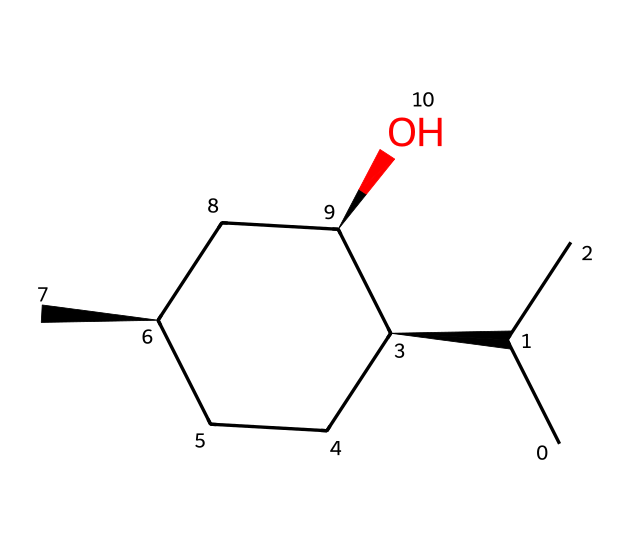What is the molecular formula of menthol? To determine the molecular formula, count the number of each type of atom present in the structure based on the SMILES. Here, there are 10 carbon atoms, 20 hydrogen atoms, and 1 oxygen atom, which results in C10H20O.
Answer: C10H20O How many chiral centers are present in menthol? Review the structure for carbon atoms bonded to four distinct groups. In menthol, there are three chiral centers, specifically at the carbons marked with specific stereochemistry.
Answer: 3 What type of isomerism does menthol exhibit? Since menthol has multiple chiral centers, it can form different stereoisomers due to different spatial arrangements of its atoms. This leads to the existence of enantiomers, thus showing optical isomerism.
Answer: optical How many oxygen atoms are in menthol? Observing the SMILES representation, there is one 'O' present, indicating a single oxygen atom in the structure.
Answer: 1 What functional group is present in menthol? The sour, fresh smell emanating from menthol is attributed to its hydroxyl (-OH) group, identifying it as an alcohol. The presence of the -OH group indicates it is a primary or tertiary alcohol based on the attached carbon structure.
Answer: alcohol What is the degree of unsaturation in menthol? The degree of unsaturation can be calculated by the formula (number of rings + number of double bonds). In menthol, there are no rings or double bonds, indicating a degree of unsaturation equal to 0.
Answer: 0 